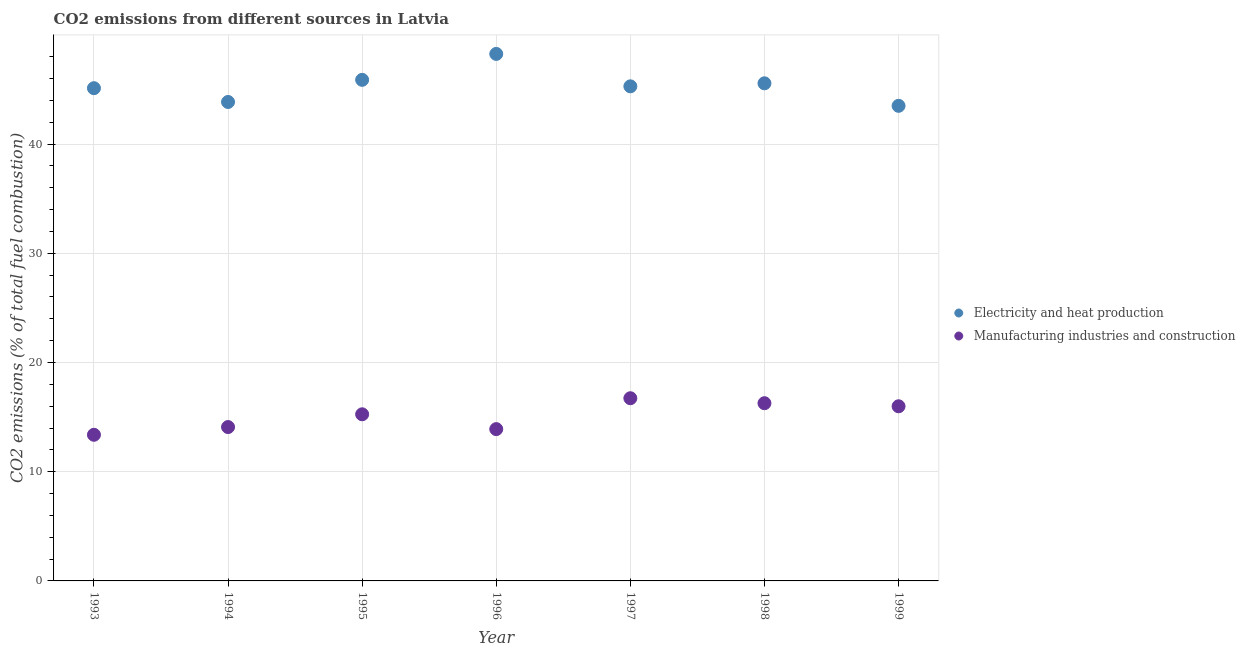Is the number of dotlines equal to the number of legend labels?
Your answer should be compact. Yes. What is the co2 emissions due to manufacturing industries in 1997?
Make the answer very short. 16.73. Across all years, what is the maximum co2 emissions due to electricity and heat production?
Give a very brief answer. 48.25. Across all years, what is the minimum co2 emissions due to electricity and heat production?
Provide a succinct answer. 43.5. What is the total co2 emissions due to electricity and heat production in the graph?
Offer a very short reply. 317.42. What is the difference between the co2 emissions due to electricity and heat production in 1994 and that in 1999?
Provide a short and direct response. 0.35. What is the difference between the co2 emissions due to manufacturing industries in 1999 and the co2 emissions due to electricity and heat production in 1998?
Make the answer very short. -29.57. What is the average co2 emissions due to electricity and heat production per year?
Offer a very short reply. 45.35. In the year 1996, what is the difference between the co2 emissions due to electricity and heat production and co2 emissions due to manufacturing industries?
Make the answer very short. 34.35. In how many years, is the co2 emissions due to manufacturing industries greater than 22 %?
Ensure brevity in your answer.  0. What is the ratio of the co2 emissions due to electricity and heat production in 1995 to that in 1998?
Provide a succinct answer. 1.01. Is the co2 emissions due to electricity and heat production in 1993 less than that in 1995?
Make the answer very short. Yes. What is the difference between the highest and the second highest co2 emissions due to electricity and heat production?
Offer a very short reply. 2.37. What is the difference between the highest and the lowest co2 emissions due to manufacturing industries?
Make the answer very short. 3.35. Is the sum of the co2 emissions due to manufacturing industries in 1998 and 1999 greater than the maximum co2 emissions due to electricity and heat production across all years?
Offer a terse response. No. Is the co2 emissions due to manufacturing industries strictly less than the co2 emissions due to electricity and heat production over the years?
Ensure brevity in your answer.  Yes. How many dotlines are there?
Offer a very short reply. 2. How many years are there in the graph?
Ensure brevity in your answer.  7. Does the graph contain any zero values?
Your answer should be very brief. No. What is the title of the graph?
Give a very brief answer. CO2 emissions from different sources in Latvia. What is the label or title of the Y-axis?
Provide a short and direct response. CO2 emissions (% of total fuel combustion). What is the CO2 emissions (% of total fuel combustion) of Electricity and heat production in 1993?
Offer a terse response. 45.11. What is the CO2 emissions (% of total fuel combustion) in Manufacturing industries and construction in 1993?
Offer a terse response. 13.38. What is the CO2 emissions (% of total fuel combustion) of Electricity and heat production in 1994?
Make the answer very short. 43.85. What is the CO2 emissions (% of total fuel combustion) of Manufacturing industries and construction in 1994?
Offer a very short reply. 14.09. What is the CO2 emissions (% of total fuel combustion) of Electricity and heat production in 1995?
Provide a short and direct response. 45.88. What is the CO2 emissions (% of total fuel combustion) of Manufacturing industries and construction in 1995?
Give a very brief answer. 15.25. What is the CO2 emissions (% of total fuel combustion) of Electricity and heat production in 1996?
Offer a very short reply. 48.25. What is the CO2 emissions (% of total fuel combustion) of Manufacturing industries and construction in 1996?
Your answer should be very brief. 13.9. What is the CO2 emissions (% of total fuel combustion) in Electricity and heat production in 1997?
Make the answer very short. 45.28. What is the CO2 emissions (% of total fuel combustion) in Manufacturing industries and construction in 1997?
Offer a terse response. 16.73. What is the CO2 emissions (% of total fuel combustion) in Electricity and heat production in 1998?
Provide a short and direct response. 45.56. What is the CO2 emissions (% of total fuel combustion) of Manufacturing industries and construction in 1998?
Offer a terse response. 16.27. What is the CO2 emissions (% of total fuel combustion) of Electricity and heat production in 1999?
Make the answer very short. 43.5. What is the CO2 emissions (% of total fuel combustion) of Manufacturing industries and construction in 1999?
Provide a succinct answer. 15.99. Across all years, what is the maximum CO2 emissions (% of total fuel combustion) in Electricity and heat production?
Your answer should be compact. 48.25. Across all years, what is the maximum CO2 emissions (% of total fuel combustion) in Manufacturing industries and construction?
Provide a succinct answer. 16.73. Across all years, what is the minimum CO2 emissions (% of total fuel combustion) in Electricity and heat production?
Your answer should be very brief. 43.5. Across all years, what is the minimum CO2 emissions (% of total fuel combustion) in Manufacturing industries and construction?
Keep it short and to the point. 13.38. What is the total CO2 emissions (% of total fuel combustion) of Electricity and heat production in the graph?
Provide a short and direct response. 317.42. What is the total CO2 emissions (% of total fuel combustion) in Manufacturing industries and construction in the graph?
Offer a terse response. 105.6. What is the difference between the CO2 emissions (% of total fuel combustion) in Electricity and heat production in 1993 and that in 1994?
Keep it short and to the point. 1.26. What is the difference between the CO2 emissions (% of total fuel combustion) of Manufacturing industries and construction in 1993 and that in 1994?
Your answer should be very brief. -0.71. What is the difference between the CO2 emissions (% of total fuel combustion) in Electricity and heat production in 1993 and that in 1995?
Offer a very short reply. -0.76. What is the difference between the CO2 emissions (% of total fuel combustion) in Manufacturing industries and construction in 1993 and that in 1995?
Keep it short and to the point. -1.88. What is the difference between the CO2 emissions (% of total fuel combustion) of Electricity and heat production in 1993 and that in 1996?
Make the answer very short. -3.14. What is the difference between the CO2 emissions (% of total fuel combustion) in Manufacturing industries and construction in 1993 and that in 1996?
Provide a succinct answer. -0.52. What is the difference between the CO2 emissions (% of total fuel combustion) in Electricity and heat production in 1993 and that in 1997?
Your answer should be compact. -0.17. What is the difference between the CO2 emissions (% of total fuel combustion) of Manufacturing industries and construction in 1993 and that in 1997?
Provide a short and direct response. -3.35. What is the difference between the CO2 emissions (% of total fuel combustion) in Electricity and heat production in 1993 and that in 1998?
Your answer should be very brief. -0.45. What is the difference between the CO2 emissions (% of total fuel combustion) of Manufacturing industries and construction in 1993 and that in 1998?
Your answer should be very brief. -2.89. What is the difference between the CO2 emissions (% of total fuel combustion) in Electricity and heat production in 1993 and that in 1999?
Ensure brevity in your answer.  1.62. What is the difference between the CO2 emissions (% of total fuel combustion) in Manufacturing industries and construction in 1993 and that in 1999?
Keep it short and to the point. -2.61. What is the difference between the CO2 emissions (% of total fuel combustion) in Electricity and heat production in 1994 and that in 1995?
Provide a short and direct response. -2.03. What is the difference between the CO2 emissions (% of total fuel combustion) of Manufacturing industries and construction in 1994 and that in 1995?
Ensure brevity in your answer.  -1.17. What is the difference between the CO2 emissions (% of total fuel combustion) in Electricity and heat production in 1994 and that in 1996?
Provide a succinct answer. -4.4. What is the difference between the CO2 emissions (% of total fuel combustion) in Manufacturing industries and construction in 1994 and that in 1996?
Offer a terse response. 0.19. What is the difference between the CO2 emissions (% of total fuel combustion) in Electricity and heat production in 1994 and that in 1997?
Give a very brief answer. -1.43. What is the difference between the CO2 emissions (% of total fuel combustion) in Manufacturing industries and construction in 1994 and that in 1997?
Offer a very short reply. -2.64. What is the difference between the CO2 emissions (% of total fuel combustion) in Electricity and heat production in 1994 and that in 1998?
Offer a very short reply. -1.71. What is the difference between the CO2 emissions (% of total fuel combustion) in Manufacturing industries and construction in 1994 and that in 1998?
Your answer should be compact. -2.18. What is the difference between the CO2 emissions (% of total fuel combustion) of Electricity and heat production in 1994 and that in 1999?
Give a very brief answer. 0.35. What is the difference between the CO2 emissions (% of total fuel combustion) of Manufacturing industries and construction in 1994 and that in 1999?
Provide a succinct answer. -1.9. What is the difference between the CO2 emissions (% of total fuel combustion) in Electricity and heat production in 1995 and that in 1996?
Keep it short and to the point. -2.37. What is the difference between the CO2 emissions (% of total fuel combustion) in Manufacturing industries and construction in 1995 and that in 1996?
Keep it short and to the point. 1.36. What is the difference between the CO2 emissions (% of total fuel combustion) in Electricity and heat production in 1995 and that in 1997?
Offer a terse response. 0.59. What is the difference between the CO2 emissions (% of total fuel combustion) of Manufacturing industries and construction in 1995 and that in 1997?
Ensure brevity in your answer.  -1.47. What is the difference between the CO2 emissions (% of total fuel combustion) in Electricity and heat production in 1995 and that in 1998?
Your answer should be compact. 0.32. What is the difference between the CO2 emissions (% of total fuel combustion) in Manufacturing industries and construction in 1995 and that in 1998?
Ensure brevity in your answer.  -1.02. What is the difference between the CO2 emissions (% of total fuel combustion) in Electricity and heat production in 1995 and that in 1999?
Offer a very short reply. 2.38. What is the difference between the CO2 emissions (% of total fuel combustion) of Manufacturing industries and construction in 1995 and that in 1999?
Provide a succinct answer. -0.73. What is the difference between the CO2 emissions (% of total fuel combustion) in Electricity and heat production in 1996 and that in 1997?
Give a very brief answer. 2.97. What is the difference between the CO2 emissions (% of total fuel combustion) in Manufacturing industries and construction in 1996 and that in 1997?
Make the answer very short. -2.83. What is the difference between the CO2 emissions (% of total fuel combustion) of Electricity and heat production in 1996 and that in 1998?
Offer a very short reply. 2.69. What is the difference between the CO2 emissions (% of total fuel combustion) in Manufacturing industries and construction in 1996 and that in 1998?
Give a very brief answer. -2.37. What is the difference between the CO2 emissions (% of total fuel combustion) in Electricity and heat production in 1996 and that in 1999?
Your answer should be compact. 4.75. What is the difference between the CO2 emissions (% of total fuel combustion) of Manufacturing industries and construction in 1996 and that in 1999?
Ensure brevity in your answer.  -2.09. What is the difference between the CO2 emissions (% of total fuel combustion) of Electricity and heat production in 1997 and that in 1998?
Ensure brevity in your answer.  -0.28. What is the difference between the CO2 emissions (% of total fuel combustion) of Manufacturing industries and construction in 1997 and that in 1998?
Keep it short and to the point. 0.46. What is the difference between the CO2 emissions (% of total fuel combustion) of Electricity and heat production in 1997 and that in 1999?
Make the answer very short. 1.78. What is the difference between the CO2 emissions (% of total fuel combustion) in Manufacturing industries and construction in 1997 and that in 1999?
Make the answer very short. 0.74. What is the difference between the CO2 emissions (% of total fuel combustion) of Electricity and heat production in 1998 and that in 1999?
Ensure brevity in your answer.  2.06. What is the difference between the CO2 emissions (% of total fuel combustion) in Manufacturing industries and construction in 1998 and that in 1999?
Make the answer very short. 0.28. What is the difference between the CO2 emissions (% of total fuel combustion) in Electricity and heat production in 1993 and the CO2 emissions (% of total fuel combustion) in Manufacturing industries and construction in 1994?
Make the answer very short. 31.02. What is the difference between the CO2 emissions (% of total fuel combustion) in Electricity and heat production in 1993 and the CO2 emissions (% of total fuel combustion) in Manufacturing industries and construction in 1995?
Offer a very short reply. 29.86. What is the difference between the CO2 emissions (% of total fuel combustion) in Electricity and heat production in 1993 and the CO2 emissions (% of total fuel combustion) in Manufacturing industries and construction in 1996?
Your response must be concise. 31.21. What is the difference between the CO2 emissions (% of total fuel combustion) of Electricity and heat production in 1993 and the CO2 emissions (% of total fuel combustion) of Manufacturing industries and construction in 1997?
Ensure brevity in your answer.  28.39. What is the difference between the CO2 emissions (% of total fuel combustion) of Electricity and heat production in 1993 and the CO2 emissions (% of total fuel combustion) of Manufacturing industries and construction in 1998?
Your answer should be compact. 28.84. What is the difference between the CO2 emissions (% of total fuel combustion) of Electricity and heat production in 1993 and the CO2 emissions (% of total fuel combustion) of Manufacturing industries and construction in 1999?
Make the answer very short. 29.12. What is the difference between the CO2 emissions (% of total fuel combustion) in Electricity and heat production in 1994 and the CO2 emissions (% of total fuel combustion) in Manufacturing industries and construction in 1995?
Your response must be concise. 28.59. What is the difference between the CO2 emissions (% of total fuel combustion) in Electricity and heat production in 1994 and the CO2 emissions (% of total fuel combustion) in Manufacturing industries and construction in 1996?
Your response must be concise. 29.95. What is the difference between the CO2 emissions (% of total fuel combustion) in Electricity and heat production in 1994 and the CO2 emissions (% of total fuel combustion) in Manufacturing industries and construction in 1997?
Provide a succinct answer. 27.12. What is the difference between the CO2 emissions (% of total fuel combustion) of Electricity and heat production in 1994 and the CO2 emissions (% of total fuel combustion) of Manufacturing industries and construction in 1998?
Make the answer very short. 27.58. What is the difference between the CO2 emissions (% of total fuel combustion) in Electricity and heat production in 1994 and the CO2 emissions (% of total fuel combustion) in Manufacturing industries and construction in 1999?
Offer a very short reply. 27.86. What is the difference between the CO2 emissions (% of total fuel combustion) in Electricity and heat production in 1995 and the CO2 emissions (% of total fuel combustion) in Manufacturing industries and construction in 1996?
Your answer should be compact. 31.98. What is the difference between the CO2 emissions (% of total fuel combustion) of Electricity and heat production in 1995 and the CO2 emissions (% of total fuel combustion) of Manufacturing industries and construction in 1997?
Offer a terse response. 29.15. What is the difference between the CO2 emissions (% of total fuel combustion) of Electricity and heat production in 1995 and the CO2 emissions (% of total fuel combustion) of Manufacturing industries and construction in 1998?
Your answer should be compact. 29.61. What is the difference between the CO2 emissions (% of total fuel combustion) in Electricity and heat production in 1995 and the CO2 emissions (% of total fuel combustion) in Manufacturing industries and construction in 1999?
Offer a terse response. 29.89. What is the difference between the CO2 emissions (% of total fuel combustion) in Electricity and heat production in 1996 and the CO2 emissions (% of total fuel combustion) in Manufacturing industries and construction in 1997?
Make the answer very short. 31.52. What is the difference between the CO2 emissions (% of total fuel combustion) of Electricity and heat production in 1996 and the CO2 emissions (% of total fuel combustion) of Manufacturing industries and construction in 1998?
Provide a short and direct response. 31.98. What is the difference between the CO2 emissions (% of total fuel combustion) of Electricity and heat production in 1996 and the CO2 emissions (% of total fuel combustion) of Manufacturing industries and construction in 1999?
Your answer should be compact. 32.26. What is the difference between the CO2 emissions (% of total fuel combustion) in Electricity and heat production in 1997 and the CO2 emissions (% of total fuel combustion) in Manufacturing industries and construction in 1998?
Offer a very short reply. 29.01. What is the difference between the CO2 emissions (% of total fuel combustion) of Electricity and heat production in 1997 and the CO2 emissions (% of total fuel combustion) of Manufacturing industries and construction in 1999?
Your answer should be very brief. 29.29. What is the difference between the CO2 emissions (% of total fuel combustion) in Electricity and heat production in 1998 and the CO2 emissions (% of total fuel combustion) in Manufacturing industries and construction in 1999?
Offer a very short reply. 29.57. What is the average CO2 emissions (% of total fuel combustion) of Electricity and heat production per year?
Ensure brevity in your answer.  45.35. What is the average CO2 emissions (% of total fuel combustion) of Manufacturing industries and construction per year?
Offer a very short reply. 15.09. In the year 1993, what is the difference between the CO2 emissions (% of total fuel combustion) in Electricity and heat production and CO2 emissions (% of total fuel combustion) in Manufacturing industries and construction?
Give a very brief answer. 31.73. In the year 1994, what is the difference between the CO2 emissions (% of total fuel combustion) in Electricity and heat production and CO2 emissions (% of total fuel combustion) in Manufacturing industries and construction?
Your response must be concise. 29.76. In the year 1995, what is the difference between the CO2 emissions (% of total fuel combustion) of Electricity and heat production and CO2 emissions (% of total fuel combustion) of Manufacturing industries and construction?
Offer a very short reply. 30.62. In the year 1996, what is the difference between the CO2 emissions (% of total fuel combustion) in Electricity and heat production and CO2 emissions (% of total fuel combustion) in Manufacturing industries and construction?
Your answer should be very brief. 34.35. In the year 1997, what is the difference between the CO2 emissions (% of total fuel combustion) in Electricity and heat production and CO2 emissions (% of total fuel combustion) in Manufacturing industries and construction?
Keep it short and to the point. 28.55. In the year 1998, what is the difference between the CO2 emissions (% of total fuel combustion) in Electricity and heat production and CO2 emissions (% of total fuel combustion) in Manufacturing industries and construction?
Offer a terse response. 29.29. In the year 1999, what is the difference between the CO2 emissions (% of total fuel combustion) in Electricity and heat production and CO2 emissions (% of total fuel combustion) in Manufacturing industries and construction?
Keep it short and to the point. 27.51. What is the ratio of the CO2 emissions (% of total fuel combustion) in Electricity and heat production in 1993 to that in 1994?
Ensure brevity in your answer.  1.03. What is the ratio of the CO2 emissions (% of total fuel combustion) in Manufacturing industries and construction in 1993 to that in 1994?
Provide a short and direct response. 0.95. What is the ratio of the CO2 emissions (% of total fuel combustion) of Electricity and heat production in 1993 to that in 1995?
Give a very brief answer. 0.98. What is the ratio of the CO2 emissions (% of total fuel combustion) of Manufacturing industries and construction in 1993 to that in 1995?
Provide a succinct answer. 0.88. What is the ratio of the CO2 emissions (% of total fuel combustion) in Electricity and heat production in 1993 to that in 1996?
Provide a succinct answer. 0.94. What is the ratio of the CO2 emissions (% of total fuel combustion) of Manufacturing industries and construction in 1993 to that in 1996?
Give a very brief answer. 0.96. What is the ratio of the CO2 emissions (% of total fuel combustion) of Electricity and heat production in 1993 to that in 1997?
Provide a succinct answer. 1. What is the ratio of the CO2 emissions (% of total fuel combustion) in Manufacturing industries and construction in 1993 to that in 1997?
Offer a very short reply. 0.8. What is the ratio of the CO2 emissions (% of total fuel combustion) in Electricity and heat production in 1993 to that in 1998?
Ensure brevity in your answer.  0.99. What is the ratio of the CO2 emissions (% of total fuel combustion) in Manufacturing industries and construction in 1993 to that in 1998?
Keep it short and to the point. 0.82. What is the ratio of the CO2 emissions (% of total fuel combustion) of Electricity and heat production in 1993 to that in 1999?
Keep it short and to the point. 1.04. What is the ratio of the CO2 emissions (% of total fuel combustion) in Manufacturing industries and construction in 1993 to that in 1999?
Your answer should be compact. 0.84. What is the ratio of the CO2 emissions (% of total fuel combustion) of Electricity and heat production in 1994 to that in 1995?
Your answer should be very brief. 0.96. What is the ratio of the CO2 emissions (% of total fuel combustion) in Manufacturing industries and construction in 1994 to that in 1995?
Offer a terse response. 0.92. What is the ratio of the CO2 emissions (% of total fuel combustion) in Electricity and heat production in 1994 to that in 1996?
Your answer should be very brief. 0.91. What is the ratio of the CO2 emissions (% of total fuel combustion) of Manufacturing industries and construction in 1994 to that in 1996?
Provide a short and direct response. 1.01. What is the ratio of the CO2 emissions (% of total fuel combustion) in Electricity and heat production in 1994 to that in 1997?
Give a very brief answer. 0.97. What is the ratio of the CO2 emissions (% of total fuel combustion) of Manufacturing industries and construction in 1994 to that in 1997?
Provide a succinct answer. 0.84. What is the ratio of the CO2 emissions (% of total fuel combustion) of Electricity and heat production in 1994 to that in 1998?
Ensure brevity in your answer.  0.96. What is the ratio of the CO2 emissions (% of total fuel combustion) in Manufacturing industries and construction in 1994 to that in 1998?
Offer a terse response. 0.87. What is the ratio of the CO2 emissions (% of total fuel combustion) in Manufacturing industries and construction in 1994 to that in 1999?
Your answer should be very brief. 0.88. What is the ratio of the CO2 emissions (% of total fuel combustion) of Electricity and heat production in 1995 to that in 1996?
Give a very brief answer. 0.95. What is the ratio of the CO2 emissions (% of total fuel combustion) of Manufacturing industries and construction in 1995 to that in 1996?
Ensure brevity in your answer.  1.1. What is the ratio of the CO2 emissions (% of total fuel combustion) in Electricity and heat production in 1995 to that in 1997?
Give a very brief answer. 1.01. What is the ratio of the CO2 emissions (% of total fuel combustion) of Manufacturing industries and construction in 1995 to that in 1997?
Your answer should be very brief. 0.91. What is the ratio of the CO2 emissions (% of total fuel combustion) of Electricity and heat production in 1995 to that in 1998?
Ensure brevity in your answer.  1.01. What is the ratio of the CO2 emissions (% of total fuel combustion) in Electricity and heat production in 1995 to that in 1999?
Keep it short and to the point. 1.05. What is the ratio of the CO2 emissions (% of total fuel combustion) in Manufacturing industries and construction in 1995 to that in 1999?
Your answer should be very brief. 0.95. What is the ratio of the CO2 emissions (% of total fuel combustion) in Electricity and heat production in 1996 to that in 1997?
Offer a very short reply. 1.07. What is the ratio of the CO2 emissions (% of total fuel combustion) of Manufacturing industries and construction in 1996 to that in 1997?
Provide a short and direct response. 0.83. What is the ratio of the CO2 emissions (% of total fuel combustion) of Electricity and heat production in 1996 to that in 1998?
Keep it short and to the point. 1.06. What is the ratio of the CO2 emissions (% of total fuel combustion) in Manufacturing industries and construction in 1996 to that in 1998?
Give a very brief answer. 0.85. What is the ratio of the CO2 emissions (% of total fuel combustion) in Electricity and heat production in 1996 to that in 1999?
Your response must be concise. 1.11. What is the ratio of the CO2 emissions (% of total fuel combustion) of Manufacturing industries and construction in 1996 to that in 1999?
Provide a succinct answer. 0.87. What is the ratio of the CO2 emissions (% of total fuel combustion) of Electricity and heat production in 1997 to that in 1998?
Offer a terse response. 0.99. What is the ratio of the CO2 emissions (% of total fuel combustion) of Manufacturing industries and construction in 1997 to that in 1998?
Your answer should be very brief. 1.03. What is the ratio of the CO2 emissions (% of total fuel combustion) in Electricity and heat production in 1997 to that in 1999?
Provide a short and direct response. 1.04. What is the ratio of the CO2 emissions (% of total fuel combustion) in Manufacturing industries and construction in 1997 to that in 1999?
Make the answer very short. 1.05. What is the ratio of the CO2 emissions (% of total fuel combustion) in Electricity and heat production in 1998 to that in 1999?
Offer a very short reply. 1.05. What is the ratio of the CO2 emissions (% of total fuel combustion) of Manufacturing industries and construction in 1998 to that in 1999?
Provide a succinct answer. 1.02. What is the difference between the highest and the second highest CO2 emissions (% of total fuel combustion) of Electricity and heat production?
Offer a terse response. 2.37. What is the difference between the highest and the second highest CO2 emissions (% of total fuel combustion) in Manufacturing industries and construction?
Keep it short and to the point. 0.46. What is the difference between the highest and the lowest CO2 emissions (% of total fuel combustion) in Electricity and heat production?
Your response must be concise. 4.75. What is the difference between the highest and the lowest CO2 emissions (% of total fuel combustion) of Manufacturing industries and construction?
Your answer should be compact. 3.35. 